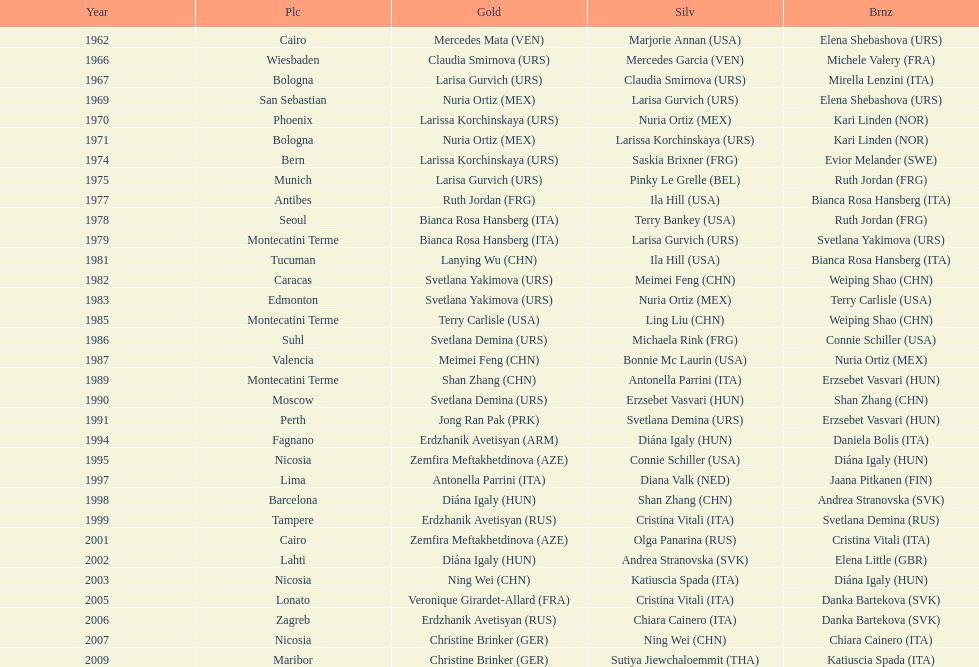Which country has the most bronze medals? Italy. 